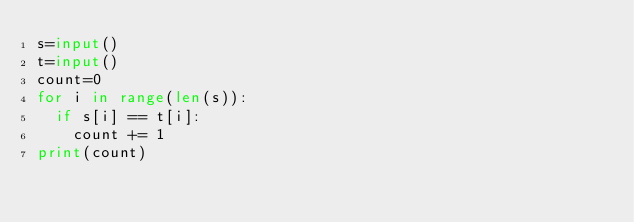<code> <loc_0><loc_0><loc_500><loc_500><_Python_>s=input()
t=input()
count=0
for i in range(len(s)):
  if s[i] == t[i]:
    count += 1
print(count)</code> 